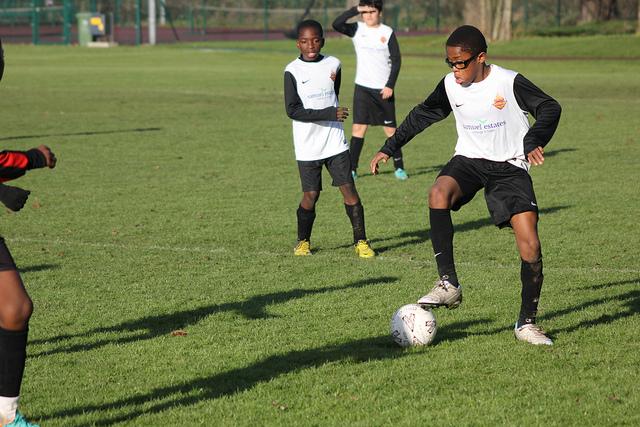Are these girls or boys playing soccer?
Answer briefly. Boys. What game are they playing?
Answer briefly. Soccer. What sport is being played?
Quick response, please. Soccer. What is the color of the grass?
Write a very short answer. Green. What color are the shorts?
Answer briefly. Black. What are the people doing?
Concise answer only. Playing soccer. What color is the ball?
Concise answer only. White. Are the people running?
Keep it brief. Yes. 